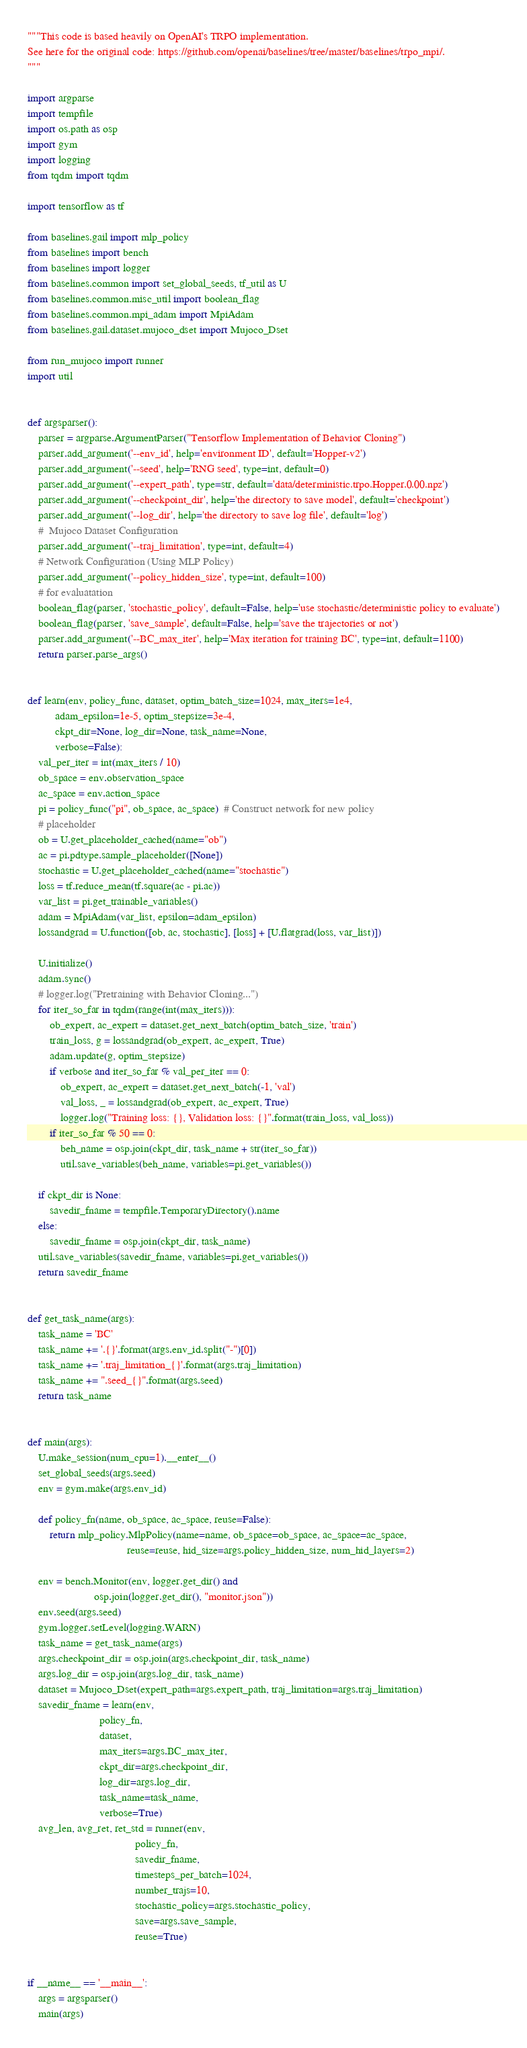<code> <loc_0><loc_0><loc_500><loc_500><_Python_>"""This code is based heavily on OpenAI's TRPO implementation.
See here for the original code: https://github.com/openai/baselines/tree/master/baselines/trpo_mpi/.
"""

import argparse
import tempfile
import os.path as osp
import gym
import logging
from tqdm import tqdm

import tensorflow as tf

from baselines.gail import mlp_policy
from baselines import bench
from baselines import logger
from baselines.common import set_global_seeds, tf_util as U
from baselines.common.misc_util import boolean_flag
from baselines.common.mpi_adam import MpiAdam
from baselines.gail.dataset.mujoco_dset import Mujoco_Dset

from run_mujoco import runner
import util


def argsparser():
    parser = argparse.ArgumentParser("Tensorflow Implementation of Behavior Cloning")
    parser.add_argument('--env_id', help='environment ID', default='Hopper-v2')
    parser.add_argument('--seed', help='RNG seed', type=int, default=0)
    parser.add_argument('--expert_path', type=str, default='data/deterministic.trpo.Hopper.0.00.npz')
    parser.add_argument('--checkpoint_dir', help='the directory to save model', default='checkpoint')
    parser.add_argument('--log_dir', help='the directory to save log file', default='log')
    #  Mujoco Dataset Configuration
    parser.add_argument('--traj_limitation', type=int, default=4)
    # Network Configuration (Using MLP Policy)
    parser.add_argument('--policy_hidden_size', type=int, default=100)
    # for evaluatation
    boolean_flag(parser, 'stochastic_policy', default=False, help='use stochastic/deterministic policy to evaluate')
    boolean_flag(parser, 'save_sample', default=False, help='save the trajectories or not')
    parser.add_argument('--BC_max_iter', help='Max iteration for training BC', type=int, default=1100)
    return parser.parse_args()


def learn(env, policy_func, dataset, optim_batch_size=1024, max_iters=1e4,
          adam_epsilon=1e-5, optim_stepsize=3e-4,
          ckpt_dir=None, log_dir=None, task_name=None,
          verbose=False):
    val_per_iter = int(max_iters / 10)
    ob_space = env.observation_space
    ac_space = env.action_space
    pi = policy_func("pi", ob_space, ac_space)  # Construct network for new policy
    # placeholder
    ob = U.get_placeholder_cached(name="ob")
    ac = pi.pdtype.sample_placeholder([None])
    stochastic = U.get_placeholder_cached(name="stochastic")
    loss = tf.reduce_mean(tf.square(ac - pi.ac))
    var_list = pi.get_trainable_variables()
    adam = MpiAdam(var_list, epsilon=adam_epsilon)
    lossandgrad = U.function([ob, ac, stochastic], [loss] + [U.flatgrad(loss, var_list)])

    U.initialize()
    adam.sync()
    # logger.log("Pretraining with Behavior Cloning...")
    for iter_so_far in tqdm(range(int(max_iters))):
        ob_expert, ac_expert = dataset.get_next_batch(optim_batch_size, 'train')
        train_loss, g = lossandgrad(ob_expert, ac_expert, True)
        adam.update(g, optim_stepsize)
        if verbose and iter_so_far % val_per_iter == 0:
            ob_expert, ac_expert = dataset.get_next_batch(-1, 'val')
            val_loss, _ = lossandgrad(ob_expert, ac_expert, True)
            logger.log("Training loss: {}, Validation loss: {}".format(train_loss, val_loss))
        if iter_so_far % 50 == 0:
            beh_name = osp.join(ckpt_dir, task_name + str(iter_so_far))
            util.save_variables(beh_name, variables=pi.get_variables())

    if ckpt_dir is None:
        savedir_fname = tempfile.TemporaryDirectory().name
    else:
        savedir_fname = osp.join(ckpt_dir, task_name)
    util.save_variables(savedir_fname, variables=pi.get_variables())
    return savedir_fname


def get_task_name(args):
    task_name = 'BC'
    task_name += '.{}'.format(args.env_id.split("-")[0])
    task_name += '.traj_limitation_{}'.format(args.traj_limitation)
    task_name += ".seed_{}".format(args.seed)
    return task_name


def main(args):
    U.make_session(num_cpu=1).__enter__()
    set_global_seeds(args.seed)
    env = gym.make(args.env_id)

    def policy_fn(name, ob_space, ac_space, reuse=False):
        return mlp_policy.MlpPolicy(name=name, ob_space=ob_space, ac_space=ac_space,
                                    reuse=reuse, hid_size=args.policy_hidden_size, num_hid_layers=2)

    env = bench.Monitor(env, logger.get_dir() and
                        osp.join(logger.get_dir(), "monitor.json"))
    env.seed(args.seed)
    gym.logger.setLevel(logging.WARN)
    task_name = get_task_name(args)
    args.checkpoint_dir = osp.join(args.checkpoint_dir, task_name)
    args.log_dir = osp.join(args.log_dir, task_name)
    dataset = Mujoco_Dset(expert_path=args.expert_path, traj_limitation=args.traj_limitation)
    savedir_fname = learn(env,
                          policy_fn,
                          dataset,
                          max_iters=args.BC_max_iter,
                          ckpt_dir=args.checkpoint_dir,
                          log_dir=args.log_dir,
                          task_name=task_name,
                          verbose=True)
    avg_len, avg_ret, ret_std = runner(env,
                                       policy_fn,
                                       savedir_fname,
                                       timesteps_per_batch=1024,
                                       number_trajs=10,
                                       stochastic_policy=args.stochastic_policy,
                                       save=args.save_sample,
                                       reuse=True)


if __name__ == '__main__':
    args = argsparser()
    main(args)
</code> 